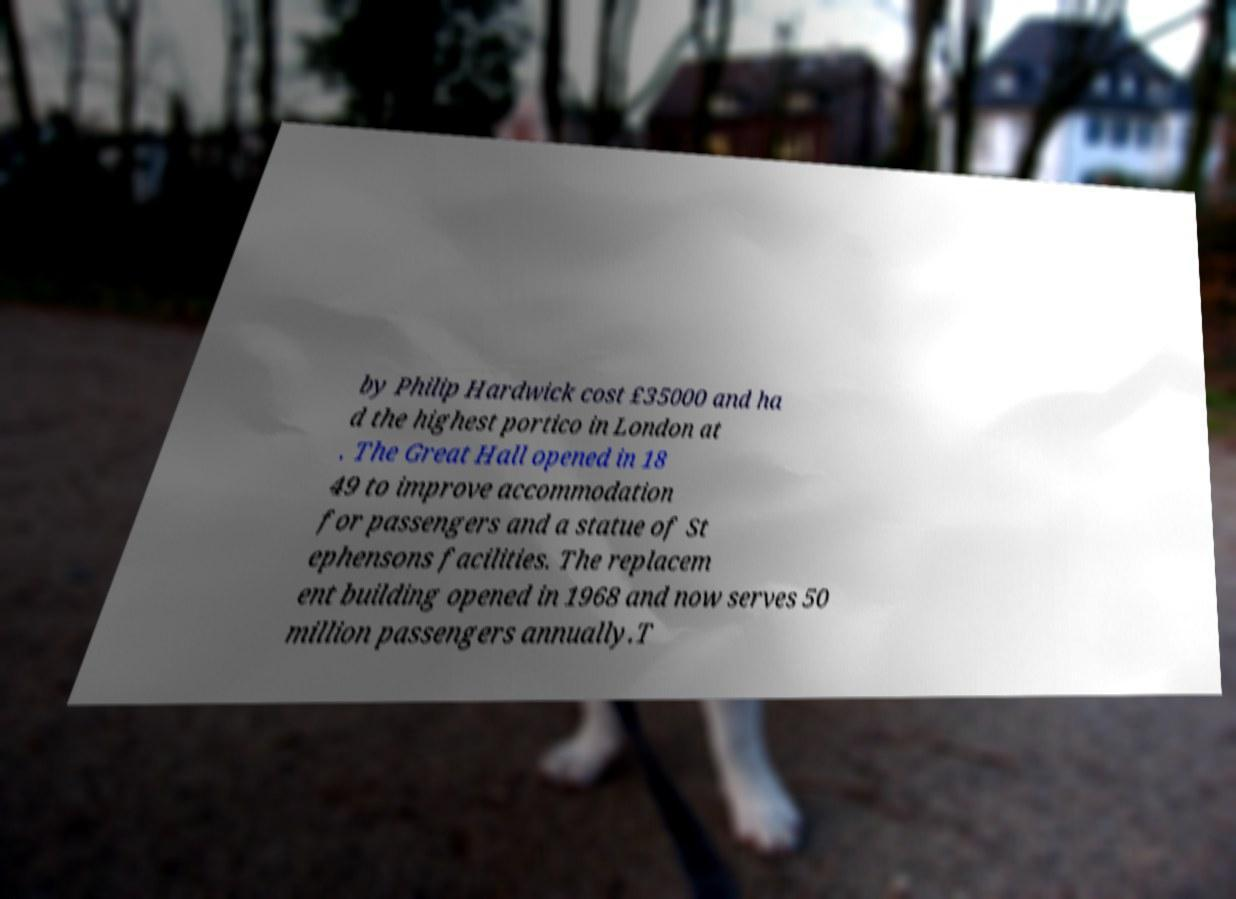I need the written content from this picture converted into text. Can you do that? by Philip Hardwick cost £35000 and ha d the highest portico in London at . The Great Hall opened in 18 49 to improve accommodation for passengers and a statue of St ephensons facilities. The replacem ent building opened in 1968 and now serves 50 million passengers annually.T 